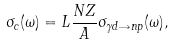Convert formula to latex. <formula><loc_0><loc_0><loc_500><loc_500>\sigma _ { c } ( \omega ) = L \frac { N Z } { A } \sigma _ { \gamma d \rightarrow n p } ( \omega ) ,</formula> 